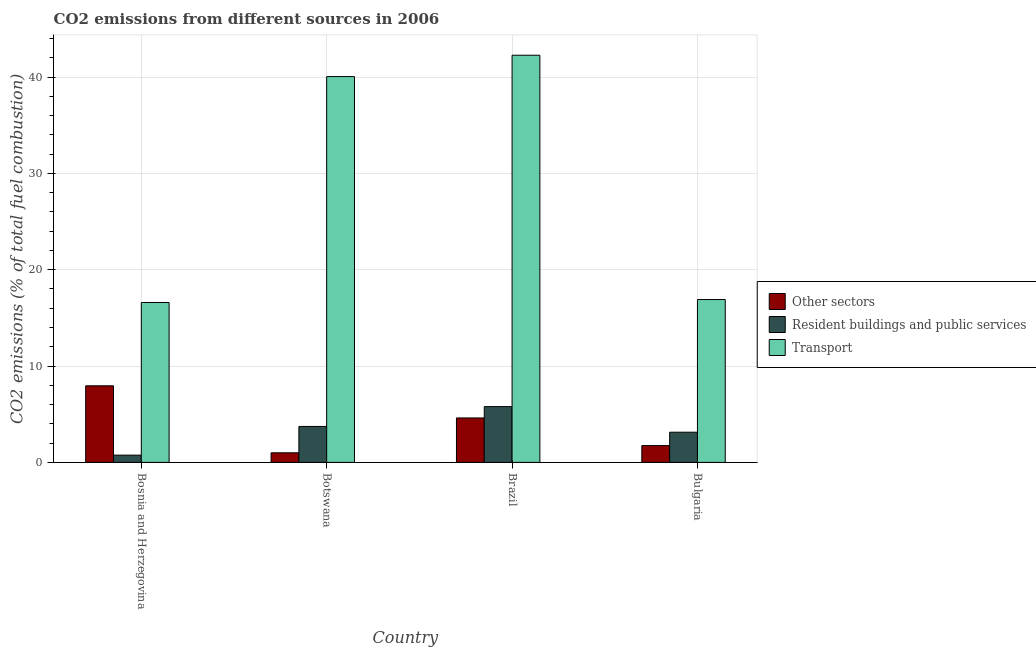Are the number of bars on each tick of the X-axis equal?
Provide a short and direct response. Yes. What is the percentage of co2 emissions from other sectors in Bosnia and Herzegovina?
Offer a terse response. 7.95. Across all countries, what is the maximum percentage of co2 emissions from transport?
Offer a very short reply. 42.27. Across all countries, what is the minimum percentage of co2 emissions from transport?
Ensure brevity in your answer.  16.6. In which country was the percentage of co2 emissions from transport maximum?
Give a very brief answer. Brazil. In which country was the percentage of co2 emissions from transport minimum?
Provide a short and direct response. Bosnia and Herzegovina. What is the total percentage of co2 emissions from other sectors in the graph?
Ensure brevity in your answer.  15.31. What is the difference between the percentage of co2 emissions from transport in Bosnia and Herzegovina and that in Bulgaria?
Offer a terse response. -0.31. What is the difference between the percentage of co2 emissions from transport in Botswana and the percentage of co2 emissions from resident buildings and public services in Bosnia and Herzegovina?
Offer a terse response. 39.3. What is the average percentage of co2 emissions from resident buildings and public services per country?
Keep it short and to the point. 3.35. What is the difference between the percentage of co2 emissions from other sectors and percentage of co2 emissions from transport in Brazil?
Keep it short and to the point. -37.65. In how many countries, is the percentage of co2 emissions from other sectors greater than 22 %?
Keep it short and to the point. 0. What is the ratio of the percentage of co2 emissions from transport in Botswana to that in Bulgaria?
Give a very brief answer. 2.37. Is the difference between the percentage of co2 emissions from transport in Bosnia and Herzegovina and Brazil greater than the difference between the percentage of co2 emissions from resident buildings and public services in Bosnia and Herzegovina and Brazil?
Provide a succinct answer. No. What is the difference between the highest and the second highest percentage of co2 emissions from other sectors?
Make the answer very short. 3.34. What is the difference between the highest and the lowest percentage of co2 emissions from resident buildings and public services?
Offer a very short reply. 5.04. In how many countries, is the percentage of co2 emissions from resident buildings and public services greater than the average percentage of co2 emissions from resident buildings and public services taken over all countries?
Offer a very short reply. 2. What does the 3rd bar from the left in Brazil represents?
Offer a very short reply. Transport. What does the 2nd bar from the right in Bosnia and Herzegovina represents?
Your answer should be compact. Resident buildings and public services. Are all the bars in the graph horizontal?
Provide a succinct answer. No. What is the difference between two consecutive major ticks on the Y-axis?
Offer a terse response. 10. Are the values on the major ticks of Y-axis written in scientific E-notation?
Your answer should be compact. No. Does the graph contain any zero values?
Offer a terse response. No. Where does the legend appear in the graph?
Your answer should be compact. Center right. How many legend labels are there?
Ensure brevity in your answer.  3. What is the title of the graph?
Offer a very short reply. CO2 emissions from different sources in 2006. Does "Unpaid family workers" appear as one of the legend labels in the graph?
Provide a succinct answer. No. What is the label or title of the Y-axis?
Give a very brief answer. CO2 emissions (% of total fuel combustion). What is the CO2 emissions (% of total fuel combustion) of Other sectors in Bosnia and Herzegovina?
Your answer should be compact. 7.95. What is the CO2 emissions (% of total fuel combustion) in Resident buildings and public services in Bosnia and Herzegovina?
Your response must be concise. 0.75. What is the CO2 emissions (% of total fuel combustion) of Transport in Bosnia and Herzegovina?
Offer a very short reply. 16.6. What is the CO2 emissions (% of total fuel combustion) of Other sectors in Botswana?
Offer a terse response. 1. What is the CO2 emissions (% of total fuel combustion) of Resident buildings and public services in Botswana?
Offer a very short reply. 3.73. What is the CO2 emissions (% of total fuel combustion) of Transport in Botswana?
Your answer should be very brief. 40.05. What is the CO2 emissions (% of total fuel combustion) of Other sectors in Brazil?
Keep it short and to the point. 4.61. What is the CO2 emissions (% of total fuel combustion) in Resident buildings and public services in Brazil?
Provide a succinct answer. 5.79. What is the CO2 emissions (% of total fuel combustion) in Transport in Brazil?
Offer a very short reply. 42.27. What is the CO2 emissions (% of total fuel combustion) of Other sectors in Bulgaria?
Provide a succinct answer. 1.75. What is the CO2 emissions (% of total fuel combustion) in Resident buildings and public services in Bulgaria?
Offer a very short reply. 3.13. What is the CO2 emissions (% of total fuel combustion) in Transport in Bulgaria?
Offer a very short reply. 16.9. Across all countries, what is the maximum CO2 emissions (% of total fuel combustion) of Other sectors?
Provide a short and direct response. 7.95. Across all countries, what is the maximum CO2 emissions (% of total fuel combustion) in Resident buildings and public services?
Ensure brevity in your answer.  5.79. Across all countries, what is the maximum CO2 emissions (% of total fuel combustion) of Transport?
Ensure brevity in your answer.  42.27. Across all countries, what is the minimum CO2 emissions (% of total fuel combustion) in Other sectors?
Give a very brief answer. 1. Across all countries, what is the minimum CO2 emissions (% of total fuel combustion) of Resident buildings and public services?
Offer a very short reply. 0.75. Across all countries, what is the minimum CO2 emissions (% of total fuel combustion) in Transport?
Make the answer very short. 16.6. What is the total CO2 emissions (% of total fuel combustion) of Other sectors in the graph?
Ensure brevity in your answer.  15.31. What is the total CO2 emissions (% of total fuel combustion) of Resident buildings and public services in the graph?
Your response must be concise. 13.41. What is the total CO2 emissions (% of total fuel combustion) of Transport in the graph?
Ensure brevity in your answer.  115.82. What is the difference between the CO2 emissions (% of total fuel combustion) of Other sectors in Bosnia and Herzegovina and that in Botswana?
Offer a very short reply. 6.96. What is the difference between the CO2 emissions (% of total fuel combustion) in Resident buildings and public services in Bosnia and Herzegovina and that in Botswana?
Keep it short and to the point. -2.98. What is the difference between the CO2 emissions (% of total fuel combustion) in Transport in Bosnia and Herzegovina and that in Botswana?
Your answer should be very brief. -23.45. What is the difference between the CO2 emissions (% of total fuel combustion) in Other sectors in Bosnia and Herzegovina and that in Brazil?
Make the answer very short. 3.34. What is the difference between the CO2 emissions (% of total fuel combustion) of Resident buildings and public services in Bosnia and Herzegovina and that in Brazil?
Give a very brief answer. -5.04. What is the difference between the CO2 emissions (% of total fuel combustion) of Transport in Bosnia and Herzegovina and that in Brazil?
Give a very brief answer. -25.67. What is the difference between the CO2 emissions (% of total fuel combustion) of Other sectors in Bosnia and Herzegovina and that in Bulgaria?
Give a very brief answer. 6.21. What is the difference between the CO2 emissions (% of total fuel combustion) of Resident buildings and public services in Bosnia and Herzegovina and that in Bulgaria?
Ensure brevity in your answer.  -2.38. What is the difference between the CO2 emissions (% of total fuel combustion) of Transport in Bosnia and Herzegovina and that in Bulgaria?
Offer a very short reply. -0.31. What is the difference between the CO2 emissions (% of total fuel combustion) in Other sectors in Botswana and that in Brazil?
Your answer should be very brief. -3.62. What is the difference between the CO2 emissions (% of total fuel combustion) of Resident buildings and public services in Botswana and that in Brazil?
Offer a very short reply. -2.06. What is the difference between the CO2 emissions (% of total fuel combustion) in Transport in Botswana and that in Brazil?
Your answer should be very brief. -2.22. What is the difference between the CO2 emissions (% of total fuel combustion) in Other sectors in Botswana and that in Bulgaria?
Ensure brevity in your answer.  -0.75. What is the difference between the CO2 emissions (% of total fuel combustion) in Resident buildings and public services in Botswana and that in Bulgaria?
Provide a short and direct response. 0.6. What is the difference between the CO2 emissions (% of total fuel combustion) of Transport in Botswana and that in Bulgaria?
Your answer should be very brief. 23.14. What is the difference between the CO2 emissions (% of total fuel combustion) in Other sectors in Brazil and that in Bulgaria?
Your answer should be compact. 2.87. What is the difference between the CO2 emissions (% of total fuel combustion) of Resident buildings and public services in Brazil and that in Bulgaria?
Offer a very short reply. 2.66. What is the difference between the CO2 emissions (% of total fuel combustion) of Transport in Brazil and that in Bulgaria?
Provide a succinct answer. 25.36. What is the difference between the CO2 emissions (% of total fuel combustion) of Other sectors in Bosnia and Herzegovina and the CO2 emissions (% of total fuel combustion) of Resident buildings and public services in Botswana?
Keep it short and to the point. 4.22. What is the difference between the CO2 emissions (% of total fuel combustion) of Other sectors in Bosnia and Herzegovina and the CO2 emissions (% of total fuel combustion) of Transport in Botswana?
Your response must be concise. -32.1. What is the difference between the CO2 emissions (% of total fuel combustion) in Resident buildings and public services in Bosnia and Herzegovina and the CO2 emissions (% of total fuel combustion) in Transport in Botswana?
Offer a very short reply. -39.3. What is the difference between the CO2 emissions (% of total fuel combustion) of Other sectors in Bosnia and Herzegovina and the CO2 emissions (% of total fuel combustion) of Resident buildings and public services in Brazil?
Keep it short and to the point. 2.16. What is the difference between the CO2 emissions (% of total fuel combustion) in Other sectors in Bosnia and Herzegovina and the CO2 emissions (% of total fuel combustion) in Transport in Brazil?
Your answer should be compact. -34.31. What is the difference between the CO2 emissions (% of total fuel combustion) of Resident buildings and public services in Bosnia and Herzegovina and the CO2 emissions (% of total fuel combustion) of Transport in Brazil?
Make the answer very short. -41.51. What is the difference between the CO2 emissions (% of total fuel combustion) in Other sectors in Bosnia and Herzegovina and the CO2 emissions (% of total fuel combustion) in Resident buildings and public services in Bulgaria?
Offer a very short reply. 4.82. What is the difference between the CO2 emissions (% of total fuel combustion) in Other sectors in Bosnia and Herzegovina and the CO2 emissions (% of total fuel combustion) in Transport in Bulgaria?
Make the answer very short. -8.95. What is the difference between the CO2 emissions (% of total fuel combustion) in Resident buildings and public services in Bosnia and Herzegovina and the CO2 emissions (% of total fuel combustion) in Transport in Bulgaria?
Make the answer very short. -16.15. What is the difference between the CO2 emissions (% of total fuel combustion) in Other sectors in Botswana and the CO2 emissions (% of total fuel combustion) in Resident buildings and public services in Brazil?
Offer a very short reply. -4.8. What is the difference between the CO2 emissions (% of total fuel combustion) of Other sectors in Botswana and the CO2 emissions (% of total fuel combustion) of Transport in Brazil?
Provide a short and direct response. -41.27. What is the difference between the CO2 emissions (% of total fuel combustion) of Resident buildings and public services in Botswana and the CO2 emissions (% of total fuel combustion) of Transport in Brazil?
Your response must be concise. -38.53. What is the difference between the CO2 emissions (% of total fuel combustion) in Other sectors in Botswana and the CO2 emissions (% of total fuel combustion) in Resident buildings and public services in Bulgaria?
Your answer should be very brief. -2.14. What is the difference between the CO2 emissions (% of total fuel combustion) in Other sectors in Botswana and the CO2 emissions (% of total fuel combustion) in Transport in Bulgaria?
Your response must be concise. -15.91. What is the difference between the CO2 emissions (% of total fuel combustion) in Resident buildings and public services in Botswana and the CO2 emissions (% of total fuel combustion) in Transport in Bulgaria?
Offer a terse response. -13.17. What is the difference between the CO2 emissions (% of total fuel combustion) of Other sectors in Brazil and the CO2 emissions (% of total fuel combustion) of Resident buildings and public services in Bulgaria?
Give a very brief answer. 1.48. What is the difference between the CO2 emissions (% of total fuel combustion) in Other sectors in Brazil and the CO2 emissions (% of total fuel combustion) in Transport in Bulgaria?
Ensure brevity in your answer.  -12.29. What is the difference between the CO2 emissions (% of total fuel combustion) in Resident buildings and public services in Brazil and the CO2 emissions (% of total fuel combustion) in Transport in Bulgaria?
Offer a very short reply. -11.11. What is the average CO2 emissions (% of total fuel combustion) in Other sectors per country?
Provide a short and direct response. 3.83. What is the average CO2 emissions (% of total fuel combustion) in Resident buildings and public services per country?
Provide a succinct answer. 3.35. What is the average CO2 emissions (% of total fuel combustion) of Transport per country?
Offer a very short reply. 28.95. What is the difference between the CO2 emissions (% of total fuel combustion) of Other sectors and CO2 emissions (% of total fuel combustion) of Resident buildings and public services in Bosnia and Herzegovina?
Your answer should be very brief. 7.2. What is the difference between the CO2 emissions (% of total fuel combustion) of Other sectors and CO2 emissions (% of total fuel combustion) of Transport in Bosnia and Herzegovina?
Ensure brevity in your answer.  -8.65. What is the difference between the CO2 emissions (% of total fuel combustion) of Resident buildings and public services and CO2 emissions (% of total fuel combustion) of Transport in Bosnia and Herzegovina?
Provide a short and direct response. -15.84. What is the difference between the CO2 emissions (% of total fuel combustion) of Other sectors and CO2 emissions (% of total fuel combustion) of Resident buildings and public services in Botswana?
Ensure brevity in your answer.  -2.74. What is the difference between the CO2 emissions (% of total fuel combustion) of Other sectors and CO2 emissions (% of total fuel combustion) of Transport in Botswana?
Provide a succinct answer. -39.05. What is the difference between the CO2 emissions (% of total fuel combustion) in Resident buildings and public services and CO2 emissions (% of total fuel combustion) in Transport in Botswana?
Ensure brevity in your answer.  -36.32. What is the difference between the CO2 emissions (% of total fuel combustion) in Other sectors and CO2 emissions (% of total fuel combustion) in Resident buildings and public services in Brazil?
Your answer should be very brief. -1.18. What is the difference between the CO2 emissions (% of total fuel combustion) in Other sectors and CO2 emissions (% of total fuel combustion) in Transport in Brazil?
Your response must be concise. -37.65. What is the difference between the CO2 emissions (% of total fuel combustion) in Resident buildings and public services and CO2 emissions (% of total fuel combustion) in Transport in Brazil?
Offer a terse response. -36.47. What is the difference between the CO2 emissions (% of total fuel combustion) of Other sectors and CO2 emissions (% of total fuel combustion) of Resident buildings and public services in Bulgaria?
Your answer should be compact. -1.39. What is the difference between the CO2 emissions (% of total fuel combustion) in Other sectors and CO2 emissions (% of total fuel combustion) in Transport in Bulgaria?
Make the answer very short. -15.16. What is the difference between the CO2 emissions (% of total fuel combustion) in Resident buildings and public services and CO2 emissions (% of total fuel combustion) in Transport in Bulgaria?
Offer a very short reply. -13.77. What is the ratio of the CO2 emissions (% of total fuel combustion) in Other sectors in Bosnia and Herzegovina to that in Botswana?
Offer a terse response. 7.99. What is the ratio of the CO2 emissions (% of total fuel combustion) of Resident buildings and public services in Bosnia and Herzegovina to that in Botswana?
Offer a very short reply. 0.2. What is the ratio of the CO2 emissions (% of total fuel combustion) in Transport in Bosnia and Herzegovina to that in Botswana?
Ensure brevity in your answer.  0.41. What is the ratio of the CO2 emissions (% of total fuel combustion) of Other sectors in Bosnia and Herzegovina to that in Brazil?
Your response must be concise. 1.72. What is the ratio of the CO2 emissions (% of total fuel combustion) of Resident buildings and public services in Bosnia and Herzegovina to that in Brazil?
Your answer should be very brief. 0.13. What is the ratio of the CO2 emissions (% of total fuel combustion) in Transport in Bosnia and Herzegovina to that in Brazil?
Your answer should be very brief. 0.39. What is the ratio of the CO2 emissions (% of total fuel combustion) of Other sectors in Bosnia and Herzegovina to that in Bulgaria?
Provide a short and direct response. 4.56. What is the ratio of the CO2 emissions (% of total fuel combustion) of Resident buildings and public services in Bosnia and Herzegovina to that in Bulgaria?
Offer a terse response. 0.24. What is the ratio of the CO2 emissions (% of total fuel combustion) of Transport in Bosnia and Herzegovina to that in Bulgaria?
Make the answer very short. 0.98. What is the ratio of the CO2 emissions (% of total fuel combustion) of Other sectors in Botswana to that in Brazil?
Your response must be concise. 0.22. What is the ratio of the CO2 emissions (% of total fuel combustion) in Resident buildings and public services in Botswana to that in Brazil?
Provide a succinct answer. 0.64. What is the ratio of the CO2 emissions (% of total fuel combustion) of Transport in Botswana to that in Brazil?
Offer a terse response. 0.95. What is the ratio of the CO2 emissions (% of total fuel combustion) in Other sectors in Botswana to that in Bulgaria?
Provide a succinct answer. 0.57. What is the ratio of the CO2 emissions (% of total fuel combustion) of Resident buildings and public services in Botswana to that in Bulgaria?
Make the answer very short. 1.19. What is the ratio of the CO2 emissions (% of total fuel combustion) of Transport in Botswana to that in Bulgaria?
Your response must be concise. 2.37. What is the ratio of the CO2 emissions (% of total fuel combustion) in Other sectors in Brazil to that in Bulgaria?
Ensure brevity in your answer.  2.64. What is the ratio of the CO2 emissions (% of total fuel combustion) in Resident buildings and public services in Brazil to that in Bulgaria?
Your response must be concise. 1.85. What is the ratio of the CO2 emissions (% of total fuel combustion) of Transport in Brazil to that in Bulgaria?
Your response must be concise. 2.5. What is the difference between the highest and the second highest CO2 emissions (% of total fuel combustion) in Other sectors?
Offer a terse response. 3.34. What is the difference between the highest and the second highest CO2 emissions (% of total fuel combustion) in Resident buildings and public services?
Offer a very short reply. 2.06. What is the difference between the highest and the second highest CO2 emissions (% of total fuel combustion) in Transport?
Ensure brevity in your answer.  2.22. What is the difference between the highest and the lowest CO2 emissions (% of total fuel combustion) in Other sectors?
Ensure brevity in your answer.  6.96. What is the difference between the highest and the lowest CO2 emissions (% of total fuel combustion) of Resident buildings and public services?
Provide a succinct answer. 5.04. What is the difference between the highest and the lowest CO2 emissions (% of total fuel combustion) in Transport?
Ensure brevity in your answer.  25.67. 